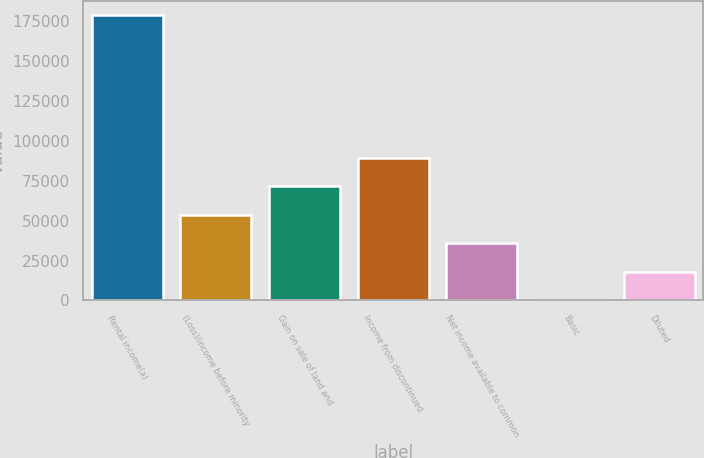<chart> <loc_0><loc_0><loc_500><loc_500><bar_chart><fcel>Rental income(a)<fcel>(Loss)/income before minority<fcel>Gain on sale of land and<fcel>Income from discontinued<fcel>Net income available to common<fcel>Basic<fcel>Diluted<nl><fcel>178231<fcel>53469.3<fcel>71292.4<fcel>89115.5<fcel>35646.2<fcel>0.01<fcel>17823.1<nl></chart> 